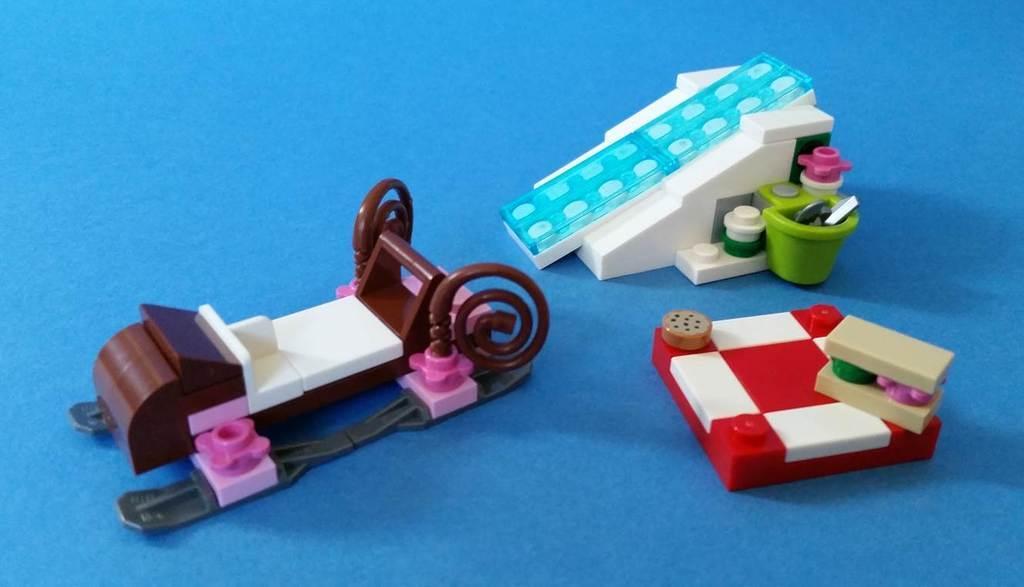In one or two sentences, can you explain what this image depicts? In this picture I can see three toys on an object. 